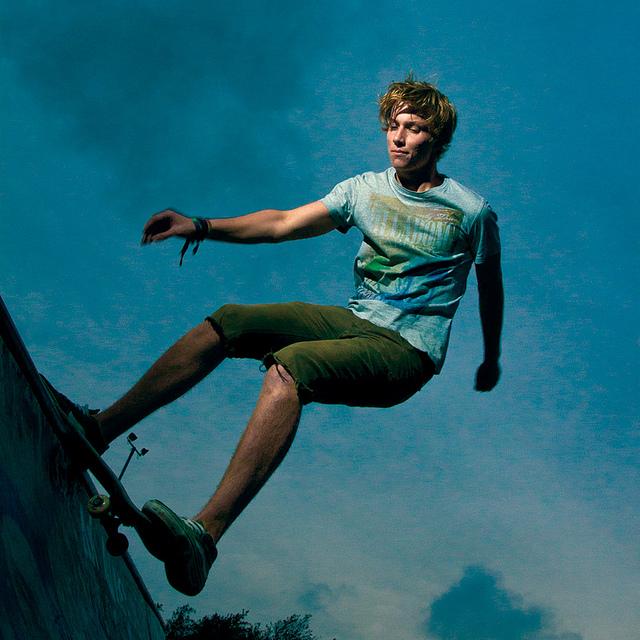What color is the man's hair?
Answer briefly. Brown. Is this boy wearing any shoes?
Keep it brief. Yes. Is this photo in black and white or color?
Answer briefly. Color. Is this a man or woman?
Keep it brief. Man. Does the man appear to be happy?
Answer briefly. Yes. 